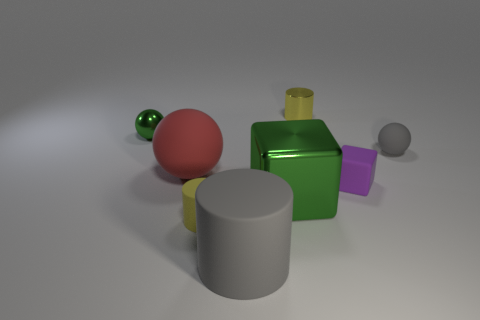Does the purple rubber cube have the same size as the gray object in front of the metallic cube?
Your answer should be compact. No. There is a yellow object in front of the metal cylinder; what material is it?
Provide a succinct answer. Rubber. What number of rubber objects are both to the left of the gray cylinder and behind the purple block?
Ensure brevity in your answer.  1. What material is the gray object that is the same size as the red rubber object?
Give a very brief answer. Rubber. There is a gray matte object that is left of the yellow metallic object; does it have the same size as the green metallic object in front of the purple object?
Keep it short and to the point. Yes. Are there any metal objects left of the large green cube?
Provide a short and direct response. Yes. There is a large object to the left of the gray matte object on the left side of the gray ball; what is its color?
Make the answer very short. Red. Is the number of yellow matte cylinders less than the number of large objects?
Provide a succinct answer. Yes. How many tiny green objects have the same shape as the large green shiny thing?
Ensure brevity in your answer.  0. What color is the other ball that is the same size as the shiny ball?
Provide a succinct answer. Gray. 